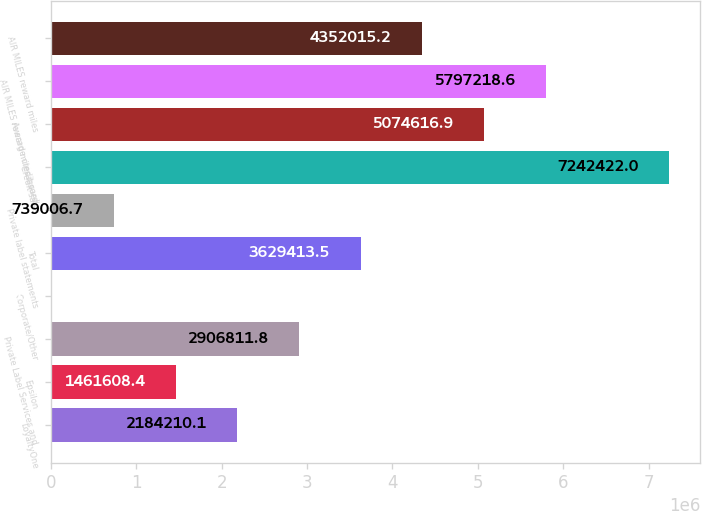Convert chart to OTSL. <chart><loc_0><loc_0><loc_500><loc_500><bar_chart><fcel>LoyaltyOne<fcel>Epsilon<fcel>Private Label Services and<fcel>Corporate/Other<fcel>Total<fcel>Private label statements<fcel>Credit sales<fcel>Average credit card<fcel>AIR MILES reward miles issued<fcel>AIR MILES reward miles<nl><fcel>2.18421e+06<fcel>1.46161e+06<fcel>2.90681e+06<fcel>16405<fcel>3.62941e+06<fcel>739007<fcel>7.24242e+06<fcel>5.07462e+06<fcel>5.79722e+06<fcel>4.35202e+06<nl></chart> 